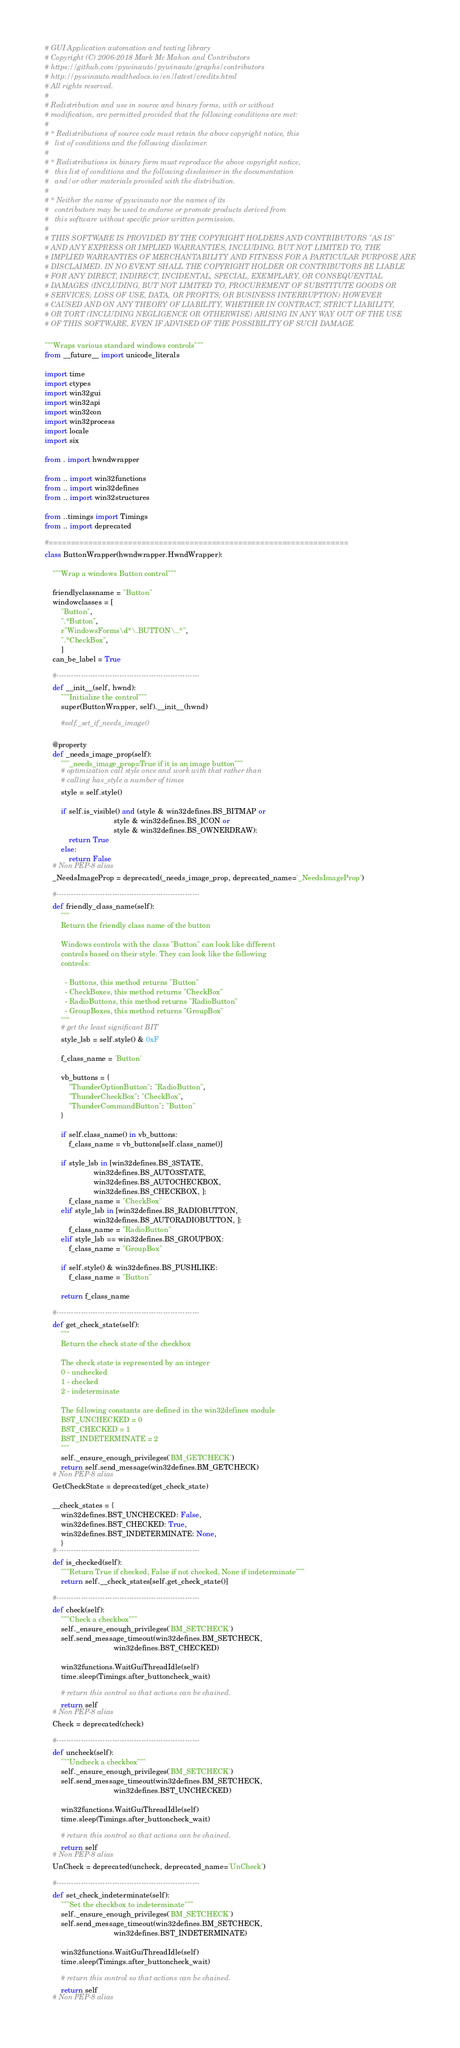<code> <loc_0><loc_0><loc_500><loc_500><_Python_># GUI Application automation and testing library
# Copyright (C) 2006-2018 Mark Mc Mahon and Contributors
# https://github.com/pywinauto/pywinauto/graphs/contributors
# http://pywinauto.readthedocs.io/en/latest/credits.html
# All rights reserved.
#
# Redistribution and use in source and binary forms, with or without
# modification, are permitted provided that the following conditions are met:
#
# * Redistributions of source code must retain the above copyright notice, this
#   list of conditions and the following disclaimer.
#
# * Redistributions in binary form must reproduce the above copyright notice,
#   this list of conditions and the following disclaimer in the documentation
#   and/or other materials provided with the distribution.
#
# * Neither the name of pywinauto nor the names of its
#   contributors may be used to endorse or promote products derived from
#   this software without specific prior written permission.
#
# THIS SOFTWARE IS PROVIDED BY THE COPYRIGHT HOLDERS AND CONTRIBUTORS "AS IS"
# AND ANY EXPRESS OR IMPLIED WARRANTIES, INCLUDING, BUT NOT LIMITED TO, THE
# IMPLIED WARRANTIES OF MERCHANTABILITY AND FITNESS FOR A PARTICULAR PURPOSE ARE
# DISCLAIMED. IN NO EVENT SHALL THE COPYRIGHT HOLDER OR CONTRIBUTORS BE LIABLE
# FOR ANY DIRECT, INDIRECT, INCIDENTAL, SPECIAL, EXEMPLARY, OR CONSEQUENTIAL
# DAMAGES (INCLUDING, BUT NOT LIMITED TO, PROCUREMENT OF SUBSTITUTE GOODS OR
# SERVICES; LOSS OF USE, DATA, OR PROFITS; OR BUSINESS INTERRUPTION) HOWEVER
# CAUSED AND ON ANY THEORY OF LIABILITY, WHETHER IN CONTRACT, STRICT LIABILITY,
# OR TORT (INCLUDING NEGLIGENCE OR OTHERWISE) ARISING IN ANY WAY OUT OF THE USE
# OF THIS SOFTWARE, EVEN IF ADVISED OF THE POSSIBILITY OF SUCH DAMAGE.

"""Wraps various standard windows controls"""
from __future__ import unicode_literals

import time
import ctypes
import win32gui
import win32api
import win32con
import win32process
import locale
import six

from . import hwndwrapper

from .. import win32functions
from .. import win32defines
from .. import win32structures

from ..timings import Timings
from .. import deprecated

#====================================================================
class ButtonWrapper(hwndwrapper.HwndWrapper):

    """Wrap a windows Button control"""

    friendlyclassname = "Button"
    windowclasses = [
        "Button",
        ".*Button",
        r"WindowsForms\d*\.BUTTON\..*",
        ".*CheckBox",
        ]
    can_be_label = True

    #-----------------------------------------------------------
    def __init__(self, hwnd):
        """Initialize the control"""
        super(ButtonWrapper, self).__init__(hwnd)

        #self._set_if_needs_image()

    @property
    def _needs_image_prop(self):
        """_needs_image_prop=True if it is an image button"""
        # optimization call style once and work with that rather than
        # calling has_style a number of times
        style = self.style()

        if self.is_visible() and (style & win32defines.BS_BITMAP or
                                  style & win32defines.BS_ICON or
                                  style & win32defines.BS_OWNERDRAW):
            return True
        else:
            return False
    # Non PEP-8 alias
    _NeedsImageProp = deprecated(_needs_image_prop, deprecated_name='_NeedsImageProp')

    #-----------------------------------------------------------
    def friendly_class_name(self):
        """
        Return the friendly class name of the button

        Windows controls with the class "Button" can look like different
        controls based on their style. They can look like the following
        controls:

          - Buttons, this method returns "Button"
          - CheckBoxes, this method returns "CheckBox"
          - RadioButtons, this method returns "RadioButton"
          - GroupBoxes, this method returns "GroupBox"
        """
        # get the least significant BIT
        style_lsb = self.style() & 0xF

        f_class_name = 'Button'

        vb_buttons = {
            "ThunderOptionButton": "RadioButton",
            "ThunderCheckBox": "CheckBox",
            "ThunderCommandButton": "Button"
        }

        if self.class_name() in vb_buttons:
            f_class_name = vb_buttons[self.class_name()]

        if style_lsb in [win32defines.BS_3STATE,
                        win32defines.BS_AUTO3STATE,
                        win32defines.BS_AUTOCHECKBOX,
                        win32defines.BS_CHECKBOX, ]:
            f_class_name = "CheckBox"
        elif style_lsb in [win32defines.BS_RADIOBUTTON,
                        win32defines.BS_AUTORADIOBUTTON, ]:
            f_class_name = "RadioButton"
        elif style_lsb == win32defines.BS_GROUPBOX:
            f_class_name = "GroupBox"

        if self.style() & win32defines.BS_PUSHLIKE:
            f_class_name = "Button"

        return f_class_name

    #-----------------------------------------------------------
    def get_check_state(self):
        """
        Return the check state of the checkbox

        The check state is represented by an integer
        0 - unchecked
        1 - checked
        2 - indeterminate

        The following constants are defined in the win32defines module
        BST_UNCHECKED = 0
        BST_CHECKED = 1
        BST_INDETERMINATE = 2
        """
        self._ensure_enough_privileges('BM_GETCHECK')
        return self.send_message(win32defines.BM_GETCHECK)
    # Non PEP-8 alias
    GetCheckState = deprecated(get_check_state)

    __check_states = {
        win32defines.BST_UNCHECKED: False,
        win32defines.BST_CHECKED: True,
        win32defines.BST_INDETERMINATE: None,
        }
    #-----------------------------------------------------------
    def is_checked(self):
        """Return True if checked, False if not checked, None if indeterminate"""
        return self.__check_states[self.get_check_state()]

    #-----------------------------------------------------------
    def check(self):
        """Check a checkbox"""
        self._ensure_enough_privileges('BM_SETCHECK')
        self.send_message_timeout(win32defines.BM_SETCHECK,
                                  win32defines.BST_CHECKED)

        win32functions.WaitGuiThreadIdle(self)
        time.sleep(Timings.after_buttoncheck_wait)

        # return this control so that actions can be chained.
        return self
    # Non PEP-8 alias
    Check = deprecated(check)

    #-----------------------------------------------------------
    def uncheck(self):
        """Uncheck a checkbox"""
        self._ensure_enough_privileges('BM_SETCHECK')
        self.send_message_timeout(win32defines.BM_SETCHECK,
                                  win32defines.BST_UNCHECKED)

        win32functions.WaitGuiThreadIdle(self)
        time.sleep(Timings.after_buttoncheck_wait)

        # return this control so that actions can be chained.
        return self
    # Non PEP-8 alias
    UnCheck = deprecated(uncheck, deprecated_name='UnCheck')

    #-----------------------------------------------------------
    def set_check_indeterminate(self):
        """Set the checkbox to indeterminate"""
        self._ensure_enough_privileges('BM_SETCHECK')
        self.send_message_timeout(win32defines.BM_SETCHECK,
                                  win32defines.BST_INDETERMINATE)

        win32functions.WaitGuiThreadIdle(self)
        time.sleep(Timings.after_buttoncheck_wait)

        # return this control so that actions can be chained.
        return self
    # Non PEP-8 alias</code> 